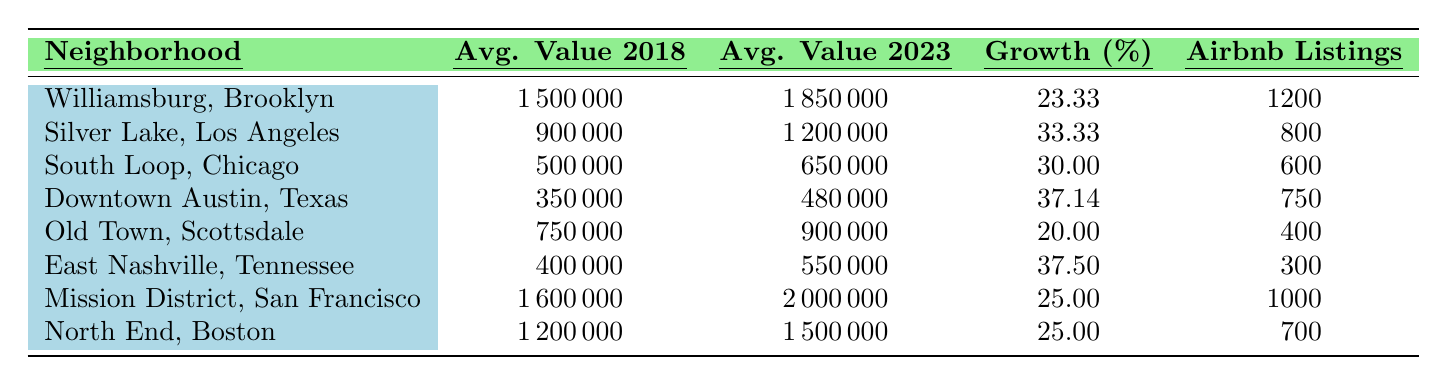What is the average property value in Williamsburg, Brooklyn, in 2023? Referring to the table, the average property value in Williamsburg, Brooklyn for 2023 is listed directly under that neighborhood, which is 1,850,000.
Answer: 1,850,000 Which neighborhood experienced the highest growth percentage in property values? By comparing the growth percentages listed, Downtown Austin, Texas, shows the highest percentage growth at 37.14% compared to other neighborhoods.
Answer: Downtown Austin, Texas What was the average property value growth percentage in Silver Lake, Los Angeles? The table specifies the growth percentage for Silver Lake, Los Angeles, which is 33.33%.
Answer: 33.33% How many Airbnb listings does East Nashville, Tennessee have? The number of Airbnb listings for East Nashville, Tennessee is listed as 300 in the table.
Answer: 300 Which neighborhood had an average property value of 1,600,000 in 2018? None of the neighborhoods listed in the table had an average property value of 1,600,000 in 2018, as the highest value recorded is in the Mission District, San Francisco, at 1,600,000.
Answer: False If we combine the average property values of South Loop, Chicago, and Old Town, Scottsdale for 2023, what will that total be? The average property value for South Loop, Chicago in 2023 is 650,000, and for Old Town, Scottsdale, it is 900,000. Combining these gives 650,000 + 900,000 = 1,550,000.
Answer: 1,550,000 What is the difference in average property values between Mission District, San Francisco in 2018 and North End, Boston in 2023? The average value for Mission District, San Francisco in 2018 is 1,600,000, while for North End, Boston in 2023, it is 1,500,000. The difference is 1,600,000 - 1,500,000 = 100,000.
Answer: 100,000 How does the average property value in 2023 for Silver Lake compare to the average value in 2018? The average property value for Silver Lake in 2023 is 1,200,000, compared to 900,000 in 2018. Comparing these values shows an increase, which establishes that the property value has grown.
Answer: Growth Which neighborhood has the fewest number of Airbnb listings? In the table, East Nashville, Tennessee is reported to have the fewest number of Airbnb listings at 300.
Answer: East Nashville, Tennessee What is the average growth percentage across all listed neighborhoods? The average growth percentage can be calculated by summing the growth percentages of all neighborhoods (23.33 + 33.33 + 30.00 + 37.14 + 20.00 + 37.50 + 25.00 + 25.00 = 261.30) and then dividing by the number of neighborhoods (8), resulting in an average of 32.66%.
Answer: 32.66% 